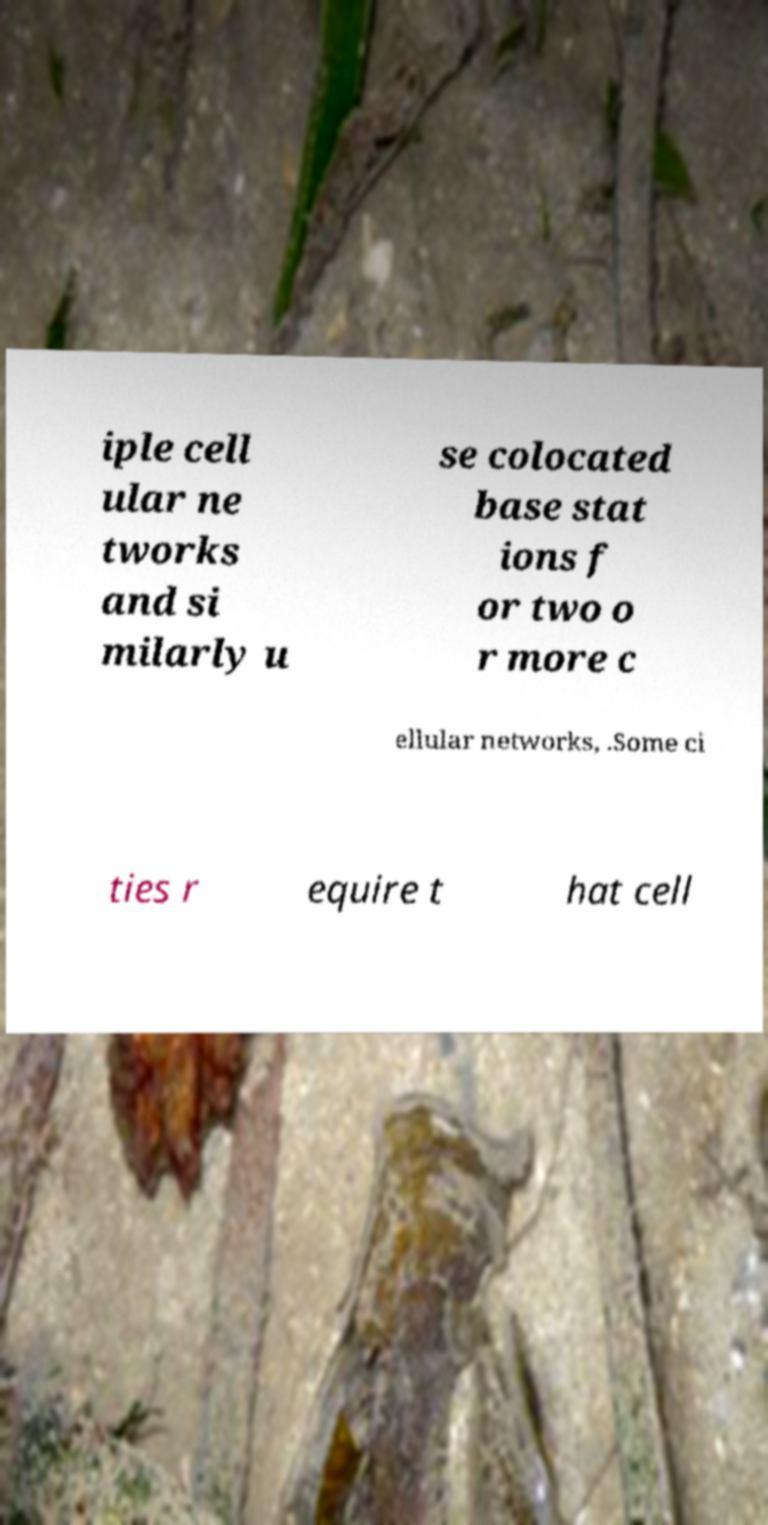There's text embedded in this image that I need extracted. Can you transcribe it verbatim? iple cell ular ne tworks and si milarly u se colocated base stat ions f or two o r more c ellular networks, .Some ci ties r equire t hat cell 